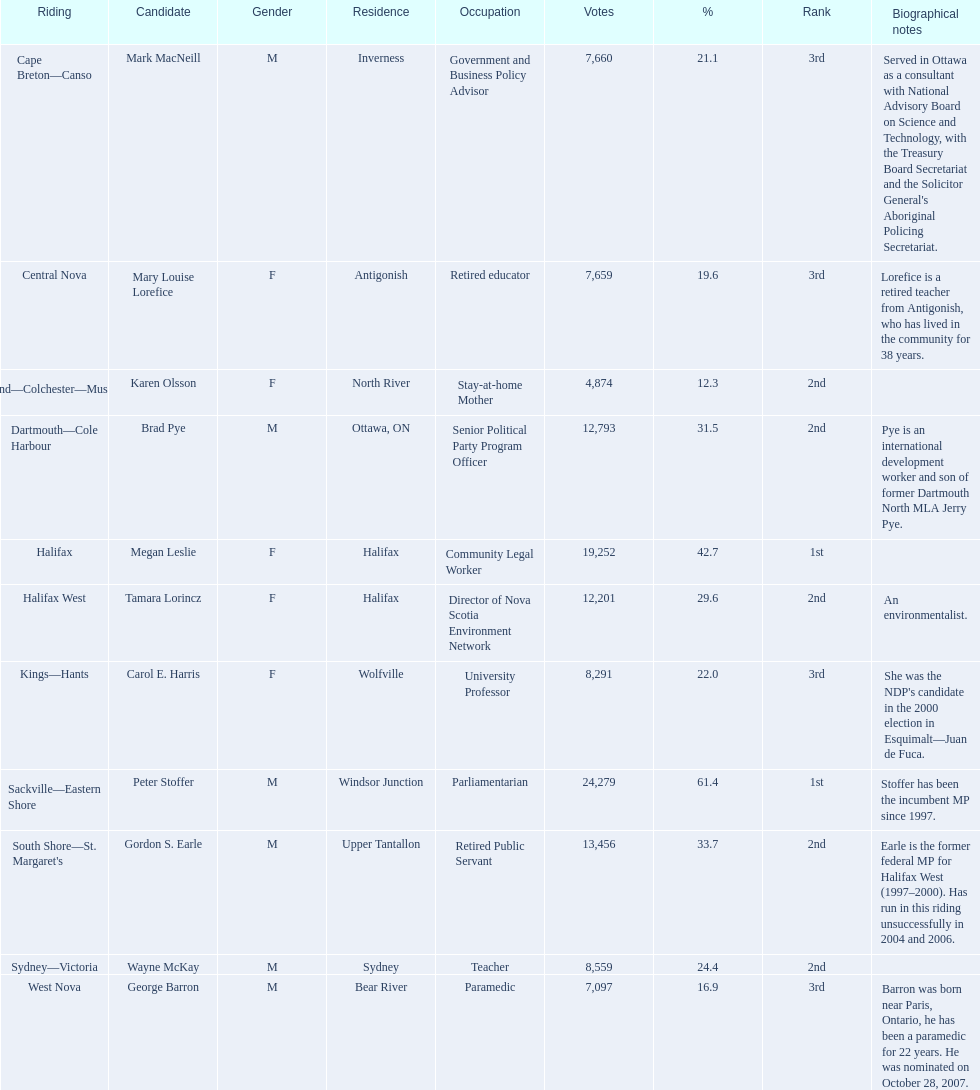Who were the new democratic party candidates, 2008? Mark MacNeill, Mary Louise Lorefice, Karen Olsson, Brad Pye, Megan Leslie, Tamara Lorincz, Carol E. Harris, Peter Stoffer, Gordon S. Earle, Wayne McKay, George Barron. Who had the 2nd highest number of votes? Megan Leslie, Peter Stoffer. How many votes did she receive? 19,252. 